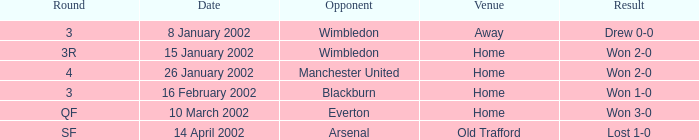What is the Date with a Round with sf? 14 April 2002. 